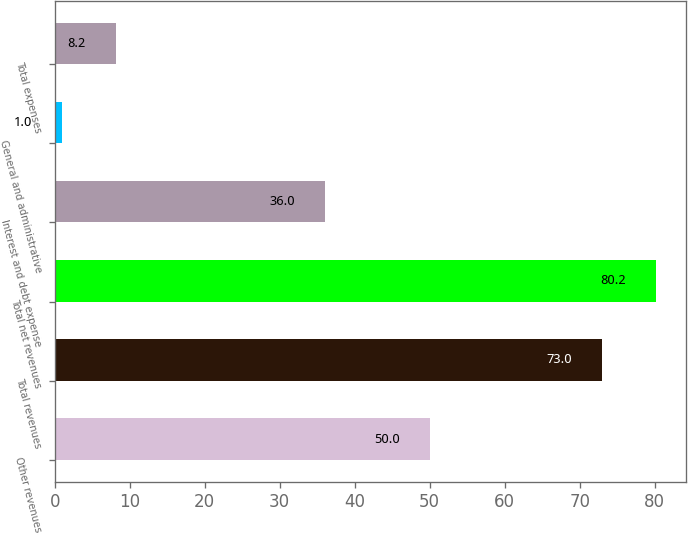Convert chart. <chart><loc_0><loc_0><loc_500><loc_500><bar_chart><fcel>Other revenues<fcel>Total revenues<fcel>Total net revenues<fcel>Interest and debt expense<fcel>General and administrative<fcel>Total expenses<nl><fcel>50<fcel>73<fcel>80.2<fcel>36<fcel>1<fcel>8.2<nl></chart> 